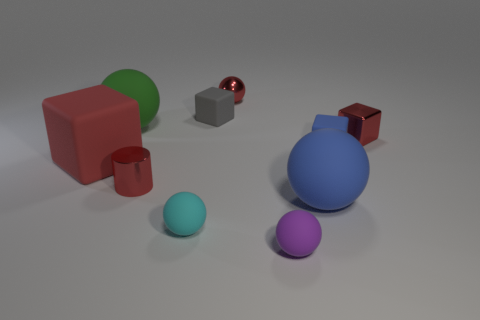How many purple spheres are the same size as the green rubber sphere? Upon examining the image, it appears that there are no purple spheres that match the size of the green rubber sphere. 